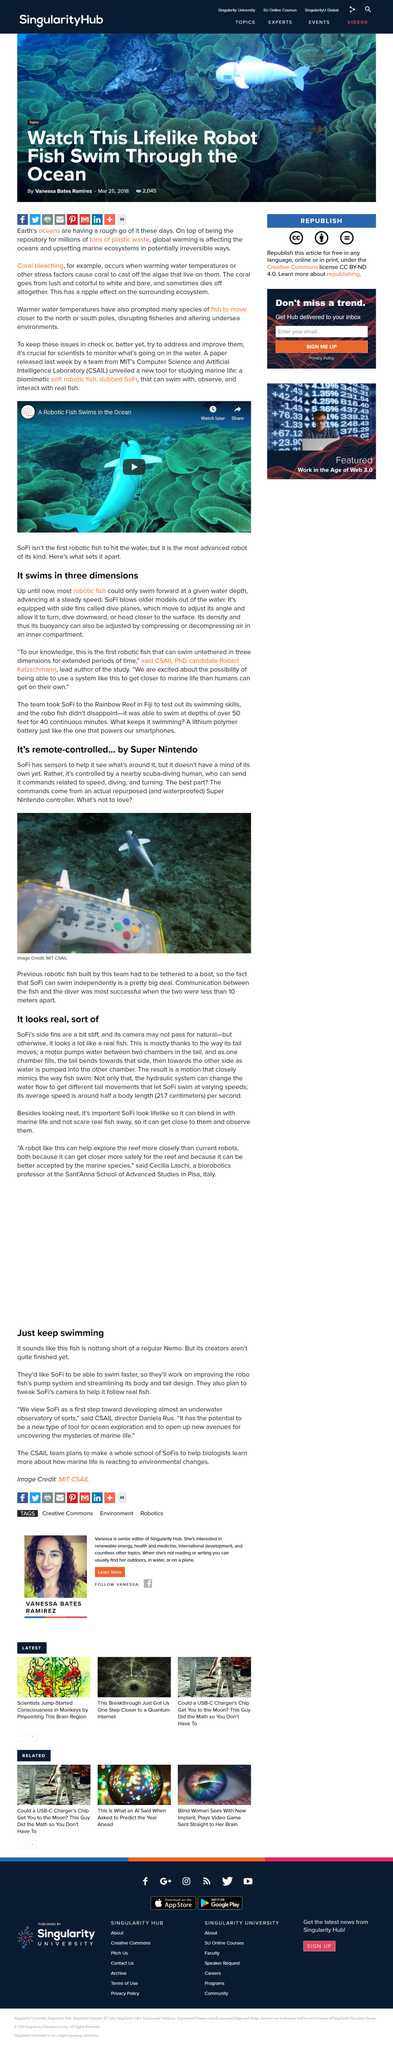Specify some key components in this picture. Fish have moved towards the north and south poles due to changes in water temperatures. What is seen swimming in the ocean, moving gracefully like a fish, is a lifelike Robor fish. Robert Katzschmann is currently pursuing his PhD at the Massachusetts Institute of Technology's Computer Science and Artificial Intelligence Laboratory (CSAIL). SoFi typically swims at an average speed of approximately 21.7 centimeters per second. SoFi appears to be a real entity. 